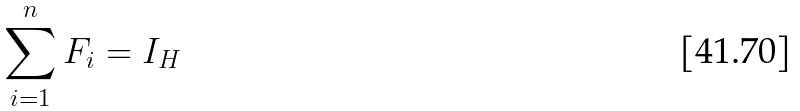<formula> <loc_0><loc_0><loc_500><loc_500>\sum _ { i = 1 } ^ { n } F _ { i } = I _ { H }</formula> 